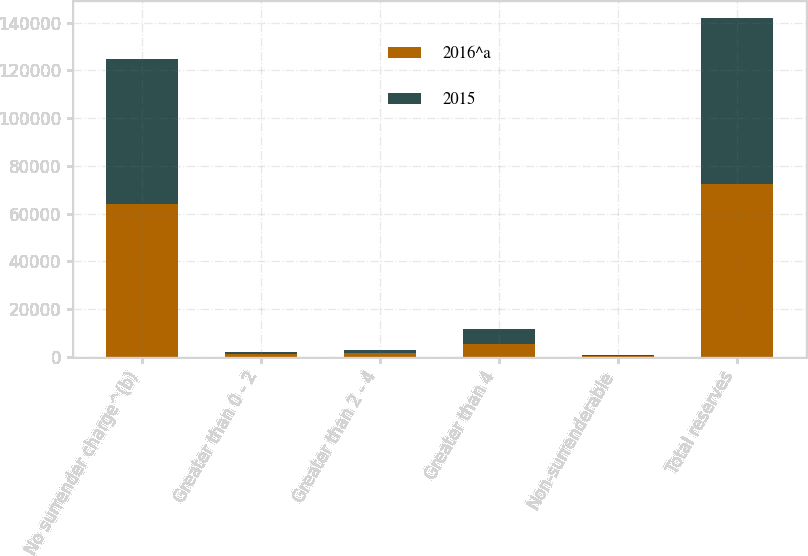<chart> <loc_0><loc_0><loc_500><loc_500><stacked_bar_chart><ecel><fcel>No surrender charge^(b)<fcel>Greater than 0 - 2<fcel>Greater than 2 - 4<fcel>Greater than 4<fcel>Non-surrenderable<fcel>Total reserves<nl><fcel>2016^a<fcel>64160<fcel>906<fcel>1395<fcel>5434<fcel>417<fcel>72312<nl><fcel>2015<fcel>60743<fcel>1200<fcel>1364<fcel>5955<fcel>360<fcel>69622<nl></chart> 